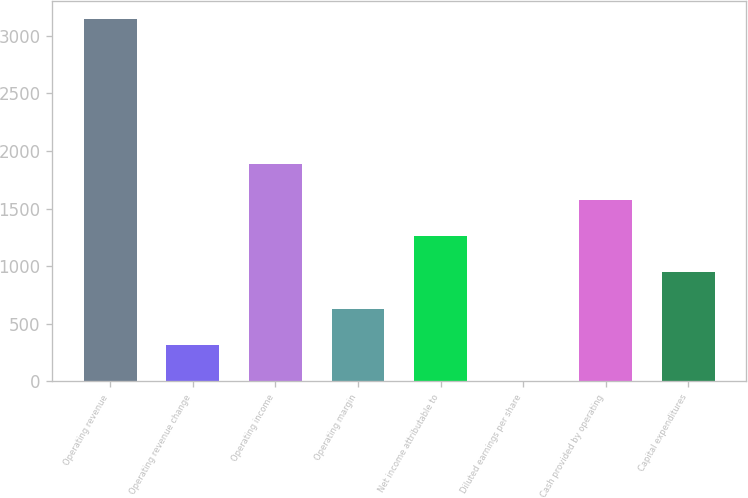<chart> <loc_0><loc_0><loc_500><loc_500><bar_chart><fcel>Operating revenue<fcel>Operating revenue change<fcel>Operating income<fcel>Operating margin<fcel>Net income attributable to<fcel>Diluted earnings per share<fcel>Cash provided by operating<fcel>Capital expenditures<nl><fcel>3144.9<fcel>318.13<fcel>1888.58<fcel>632.22<fcel>1260.4<fcel>4.04<fcel>1574.49<fcel>946.31<nl></chart> 